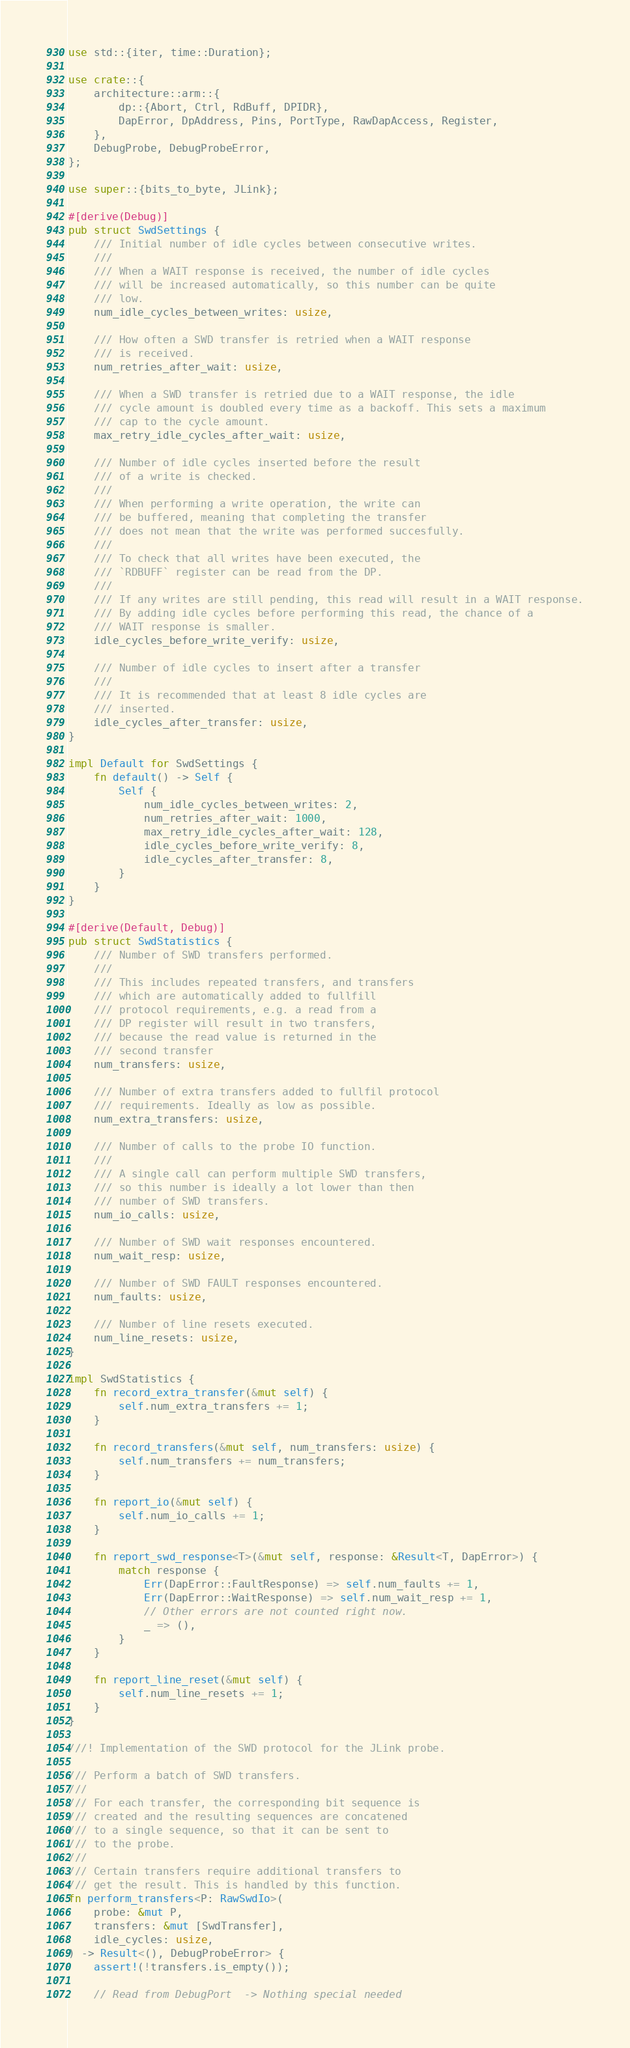Convert code to text. <code><loc_0><loc_0><loc_500><loc_500><_Rust_>use std::{iter, time::Duration};

use crate::{
    architecture::arm::{
        dp::{Abort, Ctrl, RdBuff, DPIDR},
        DapError, DpAddress, Pins, PortType, RawDapAccess, Register,
    },
    DebugProbe, DebugProbeError,
};

use super::{bits_to_byte, JLink};

#[derive(Debug)]
pub struct SwdSettings {
    /// Initial number of idle cycles between consecutive writes.
    ///
    /// When a WAIT response is received, the number of idle cycles
    /// will be increased automatically, so this number can be quite
    /// low.
    num_idle_cycles_between_writes: usize,

    /// How often a SWD transfer is retried when a WAIT response
    /// is received.
    num_retries_after_wait: usize,

    /// When a SWD transfer is retried due to a WAIT response, the idle
    /// cycle amount is doubled every time as a backoff. This sets a maximum
    /// cap to the cycle amount.
    max_retry_idle_cycles_after_wait: usize,

    /// Number of idle cycles inserted before the result
    /// of a write is checked.
    ///
    /// When performing a write operation, the write can
    /// be buffered, meaning that completing the transfer
    /// does not mean that the write was performed succesfully.
    ///
    /// To check that all writes have been executed, the
    /// `RDBUFF` register can be read from the DP.
    ///
    /// If any writes are still pending, this read will result in a WAIT response.
    /// By adding idle cycles before performing this read, the chance of a
    /// WAIT response is smaller.
    idle_cycles_before_write_verify: usize,

    /// Number of idle cycles to insert after a transfer
    ///
    /// It is recommended that at least 8 idle cycles are
    /// inserted.
    idle_cycles_after_transfer: usize,
}

impl Default for SwdSettings {
    fn default() -> Self {
        Self {
            num_idle_cycles_between_writes: 2,
            num_retries_after_wait: 1000,
            max_retry_idle_cycles_after_wait: 128,
            idle_cycles_before_write_verify: 8,
            idle_cycles_after_transfer: 8,
        }
    }
}

#[derive(Default, Debug)]
pub struct SwdStatistics {
    /// Number of SWD transfers performed.
    ///
    /// This includes repeated transfers, and transfers
    /// which are automatically added to fullfill
    /// protocol requirements, e.g. a read from a
    /// DP register will result in two transfers,
    /// because the read value is returned in the
    /// second transfer
    num_transfers: usize,

    /// Number of extra transfers added to fullfil protocol
    /// requirements. Ideally as low as possible.
    num_extra_transfers: usize,

    /// Number of calls to the probe IO function.
    ///
    /// A single call can perform multiple SWD transfers,
    /// so this number is ideally a lot lower than then
    /// number of SWD transfers.
    num_io_calls: usize,

    /// Number of SWD wait responses encountered.
    num_wait_resp: usize,

    /// Number of SWD FAULT responses encountered.
    num_faults: usize,

    /// Number of line resets executed.
    num_line_resets: usize,
}

impl SwdStatistics {
    fn record_extra_transfer(&mut self) {
        self.num_extra_transfers += 1;
    }

    fn record_transfers(&mut self, num_transfers: usize) {
        self.num_transfers += num_transfers;
    }

    fn report_io(&mut self) {
        self.num_io_calls += 1;
    }

    fn report_swd_response<T>(&mut self, response: &Result<T, DapError>) {
        match response {
            Err(DapError::FaultResponse) => self.num_faults += 1,
            Err(DapError::WaitResponse) => self.num_wait_resp += 1,
            // Other errors are not counted right now.
            _ => (),
        }
    }

    fn report_line_reset(&mut self) {
        self.num_line_resets += 1;
    }
}

///! Implementation of the SWD protocol for the JLink probe.

/// Perform a batch of SWD transfers.
///
/// For each transfer, the corresponding bit sequence is
/// created and the resulting sequences are concatened
/// to a single sequence, so that it can be sent to
/// to the probe.
///
/// Certain transfers require additional transfers to
/// get the result. This is handled by this function.
fn perform_transfers<P: RawSwdIo>(
    probe: &mut P,
    transfers: &mut [SwdTransfer],
    idle_cycles: usize,
) -> Result<(), DebugProbeError> {
    assert!(!transfers.is_empty());

    // Read from DebugPort  -> Nothing special needed</code> 